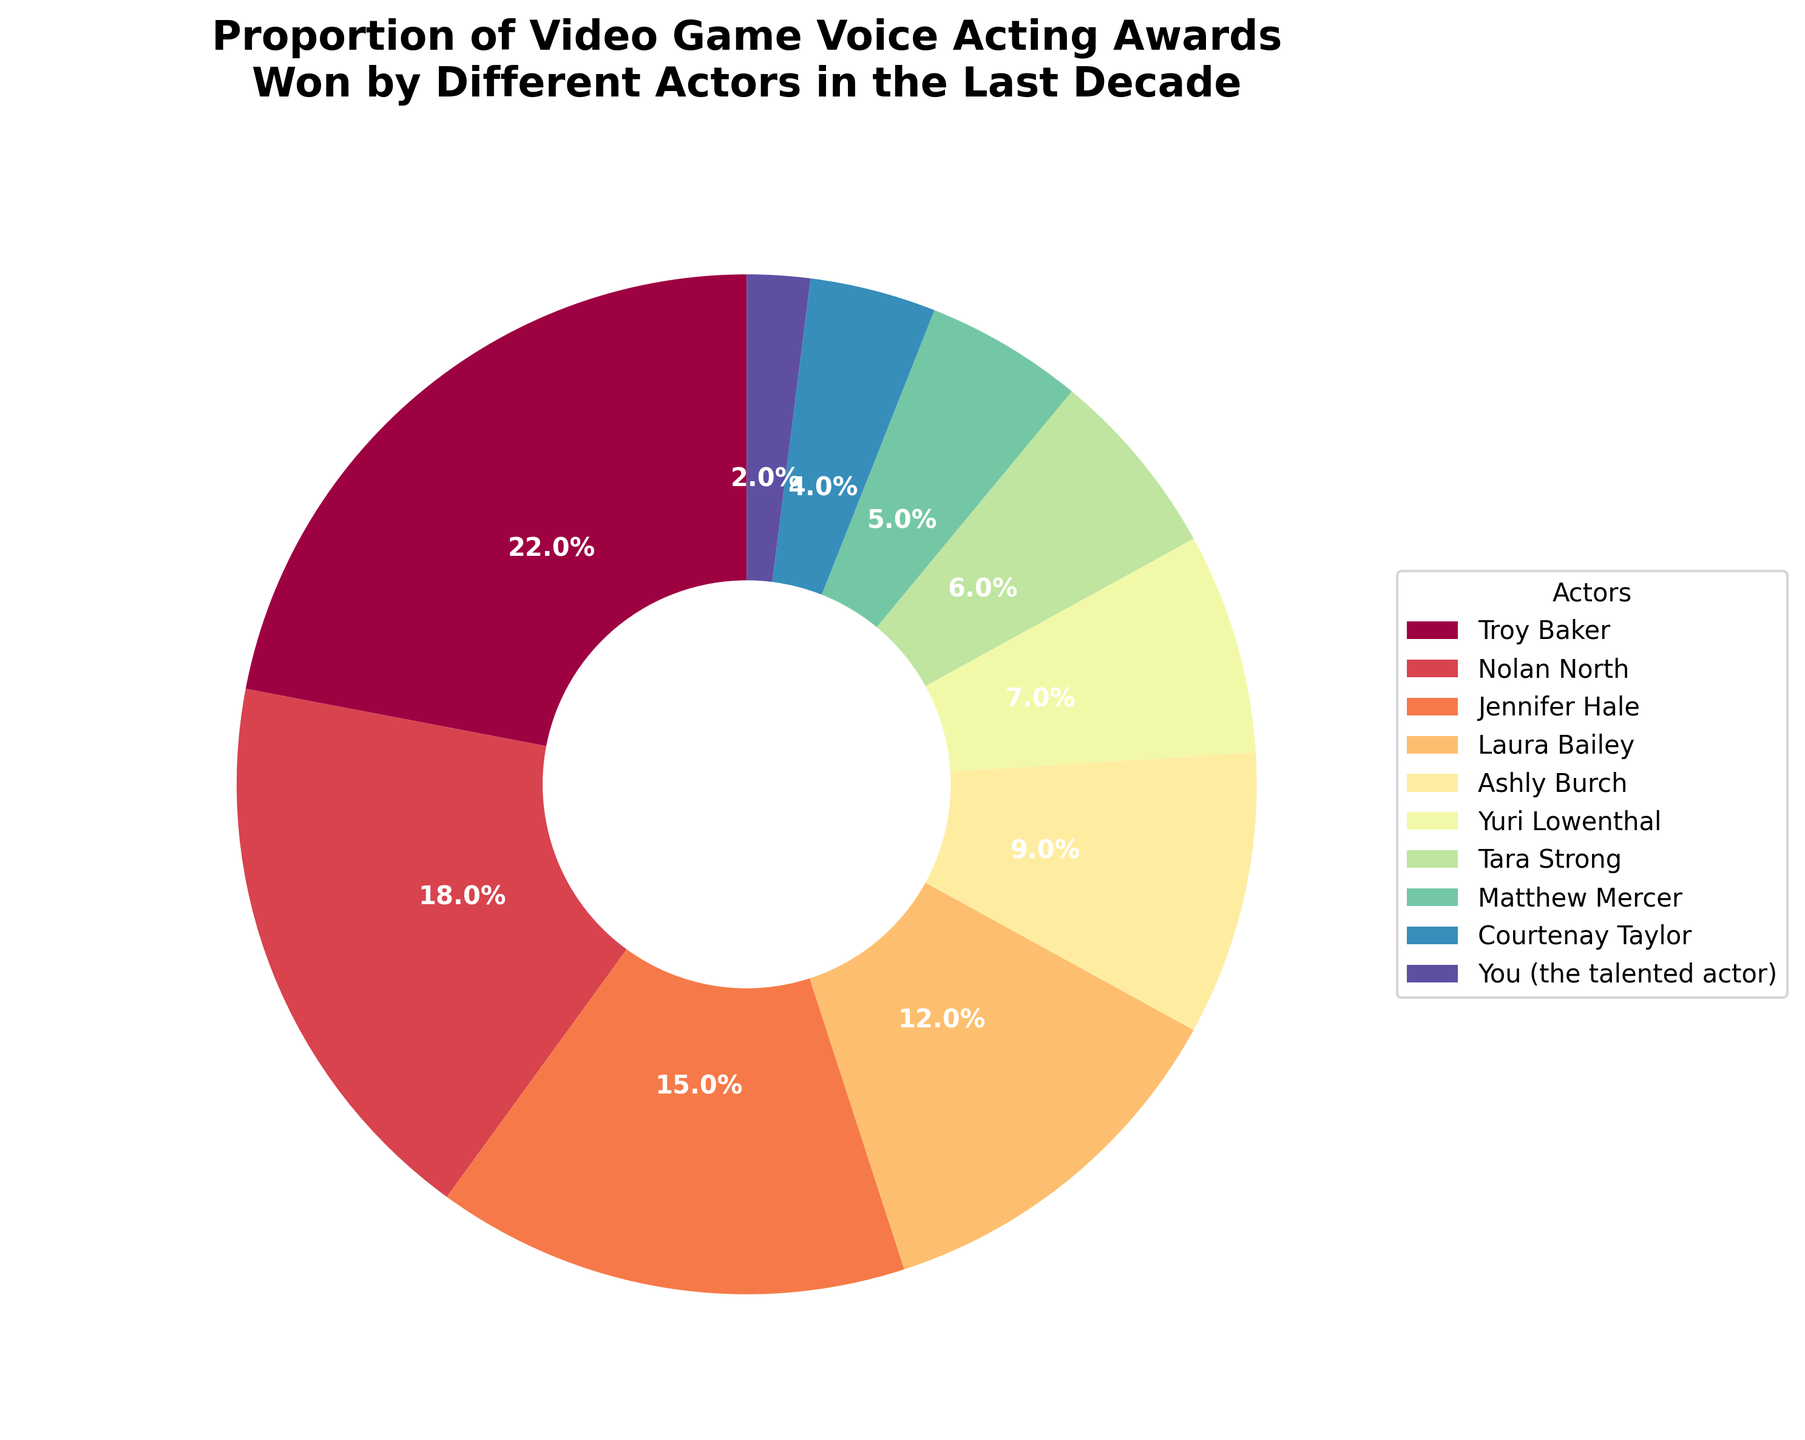Which actor won the highest proportion of video game voice acting awards in the last decade? From the figure, one can see that Troy Baker has the largest segment in the pie chart. His segment is the most prominent and visibly larger than the others.
Answer: Troy Baker How much more percentage of awards did Troy Baker win compared to Nolan North? Troy Baker's percentage is 22%, and Nolan North's percentage is 18%. Subtracting Nolan’s percentage from Troy’s gives 22 - 18 = 4%.
Answer: 4% Which three actors have the smallest proportions of awards, and what are their respective percentages? From the pie chart, the three smallest segments belong to Courtenay Taylor, the talented actor (You), and Matthew Mercer with percentages of 4%, 2%, and 5% respectively.
Answer: Courtenay Taylor (4%), You (2%), and Matthew Mercer (5%) What is the combined percentage of awards won by Jennifer Hale and Laura Bailey? Jennifer Hale’s proportion is 15% and Laura Bailey’s is 12%. Adding these together, we get 15 + 12 = 27%.
Answer: 27% How many more percentages of awards did Ashly Burch win compared to Tara Strong? Ashly Burch won 9% of the awards, whereas Tara Strong won 6%. The difference can be calculated as 9 - 6 = 3%.
Answer: 3% Who won a higher percentage of awards: Yuri Lowenthal or Tara Strong, and by how much? Yuri Lowenthal’s proportion of awards is 7%, while Tara Strong’s is 6%. Subtracting these values gives 7 - 6 = 1%.
Answer: Yuri Lowenthal by 1% What percentage of awards were won by actors other than the top three? The top three actors (Troy Baker, Nolan North, and Jennifer Hale) together won 22% + 18% + 15% = 55%. Subtracting this from 100% gives 100 - 55 = 45%.
Answer: 45% Which actor's segment is represented with the color closest to the middle of the spectrum in the pie chart? In the color scheme, the middle spectrum colors (around the halfway point) represent Laura Bailey’s segment. Her segment might fall in the green-yellow range.
Answer: Laura Bailey Which actor has an almost equal share of awards as Yuri Lowenthal, and how close is it? Matthew Mercer has a proportion of 5% and Yuri Lowenthal has 7%. The difference is 7 - 5 = 2%.
Answer: Matthew Mercer, with a 2% difference What is the visible size difference between the segment representing You (the talented actor) and Courtenay Taylor? You (the talented actor) have a 2% segment, and Courtenay Taylor has 4%. The difference is 4 - 2 = 2%.
Answer: 2% 